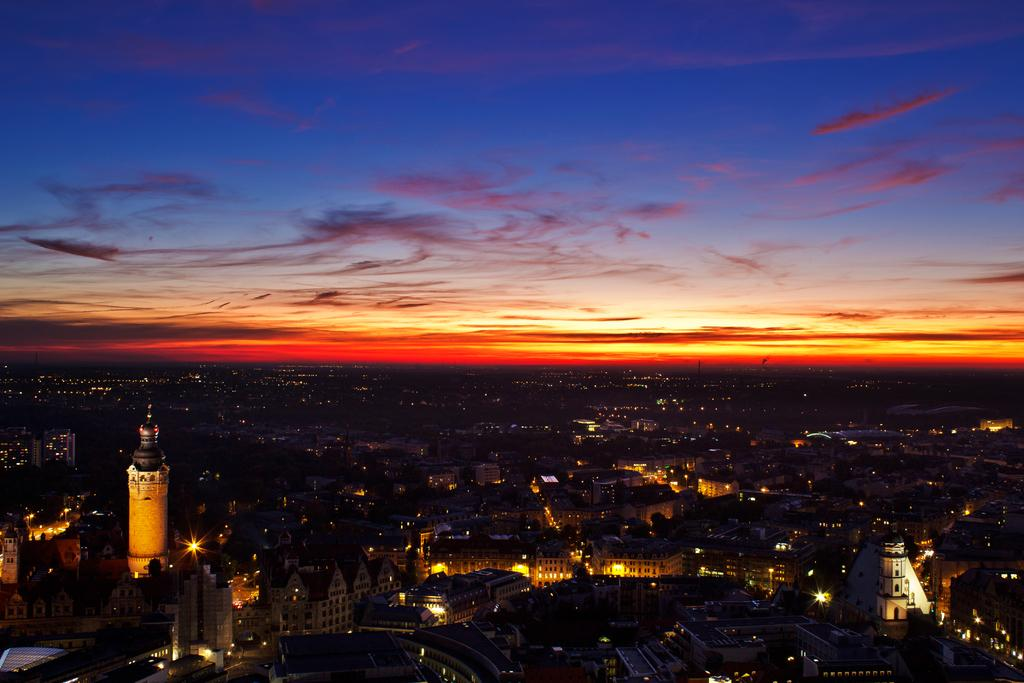What type of structures can be seen in the image? There are buildings in the image. What else is visible in the image besides the buildings? There are lights in the image. What is visible at the top of the image? The sky is visible at the top of the image. How many women are visible in the image? There are no women present in the image. Are there any mines visible in the image? There are no mines present in the image. 